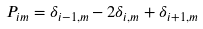Convert formula to latex. <formula><loc_0><loc_0><loc_500><loc_500>P _ { i m } = \delta _ { i - 1 , m } - 2 \delta _ { i , m } + \delta _ { i + 1 , m }</formula> 